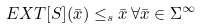Convert formula to latex. <formula><loc_0><loc_0><loc_500><loc_500>E X T [ S ] ( \bar { x } ) \leq _ { s } \bar { x } \, \forall \bar { x } \in \Sigma ^ { \infty }</formula> 